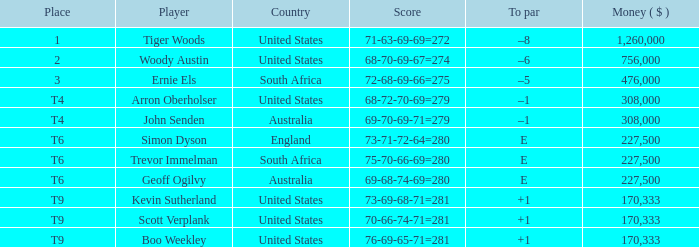What place did the player from England come in? T6. Could you parse the entire table? {'header': ['Place', 'Player', 'Country', 'Score', 'To par', 'Money ( $ )'], 'rows': [['1', 'Tiger Woods', 'United States', '71-63-69-69=272', '–8', '1,260,000'], ['2', 'Woody Austin', 'United States', '68-70-69-67=274', '–6', '756,000'], ['3', 'Ernie Els', 'South Africa', '72-68-69-66=275', '–5', '476,000'], ['T4', 'Arron Oberholser', 'United States', '68-72-70-69=279', '–1', '308,000'], ['T4', 'John Senden', 'Australia', '69-70-69-71=279', '–1', '308,000'], ['T6', 'Simon Dyson', 'England', '73-71-72-64=280', 'E', '227,500'], ['T6', 'Trevor Immelman', 'South Africa', '75-70-66-69=280', 'E', '227,500'], ['T6', 'Geoff Ogilvy', 'Australia', '69-68-74-69=280', 'E', '227,500'], ['T9', 'Kevin Sutherland', 'United States', '73-69-68-71=281', '+1', '170,333'], ['T9', 'Scott Verplank', 'United States', '70-66-74-71=281', '+1', '170,333'], ['T9', 'Boo Weekley', 'United States', '76-69-65-71=281', '+1', '170,333']]} 